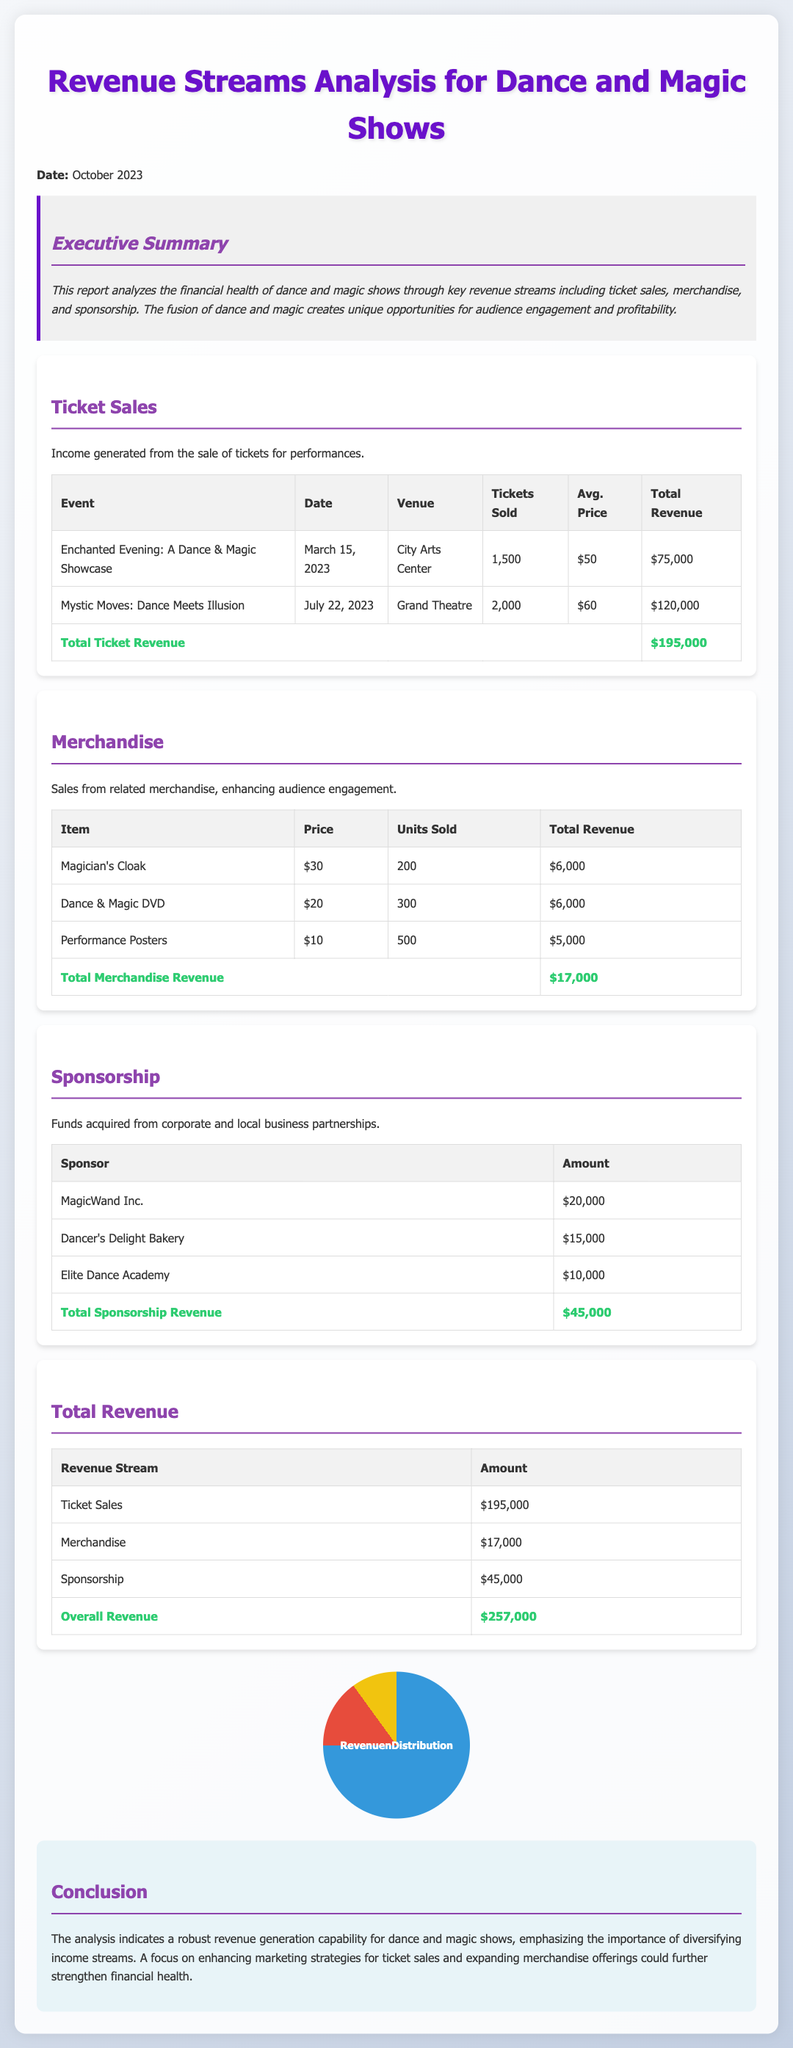What is the total ticket revenue? The total ticket revenue is calculated by adding the revenue from all ticket sales events listed in the document: $75,000 + $120,000.
Answer: $195,000 What is the total merchandise revenue? The total merchandise revenue is the sum of all revenue from merchandise items mentioned in the document: $6,000 + $6,000 + $5,000.
Answer: $17,000 What is the date of the "Mystic Moves" performance? The date for the "Mystic Moves" performance is specified in the document.
Answer: July 22, 2023 Who is the sponsor providing the highest amount of funding? The highest funding sponsor can be identified from the sponsorship table included in the document.
Answer: MagicWand Inc What is the average ticket price for the "Enchanted Evening"? The average ticket price can be found by checking the ticket details for that specific event.
Answer: $50 What percentage of overall revenue comes from ticket sales? The percentage from ticket sales is determined by the equation: (Ticket Sales / Overall Revenue) * 100.
Answer: 75.9% What is the total sponsorship revenue? The total sponsorship revenue is the aggregation of all amounts provided by listed sponsors.
Answer: $45,000 What merchandise item generated the least revenue? The item generating the least revenue can be identified by comparing the total revenue of each merchandise item.
Answer: Performance Posters What is the total number of tickets sold for all events? The total tickets sold is the sum of the tickets sold for both events, stated in the ticket sales section.
Answer: 3,500 What is emphasized as a potential area for revenue enhancement? The conclusion mentions a specific area that could be focused on to enhance revenue.
Answer: Marketing strategies 